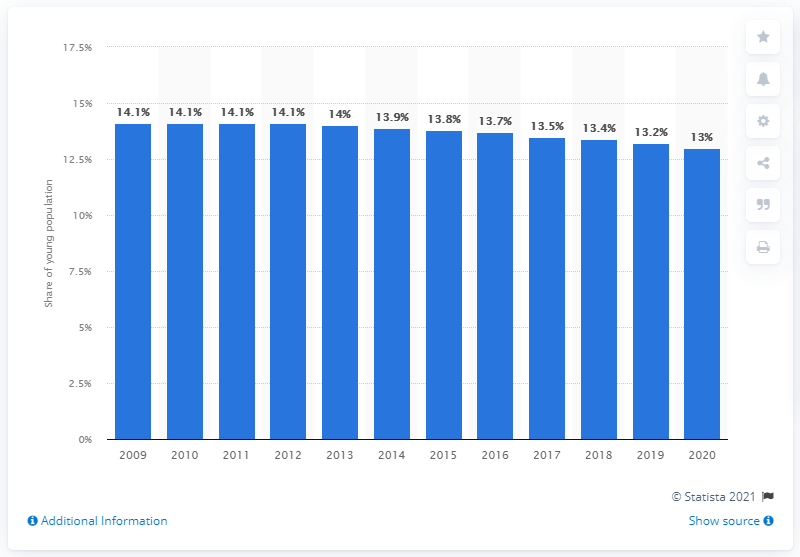Identify some key points in this picture. In 2020, approximately 13% of the young population in Italy was present. 